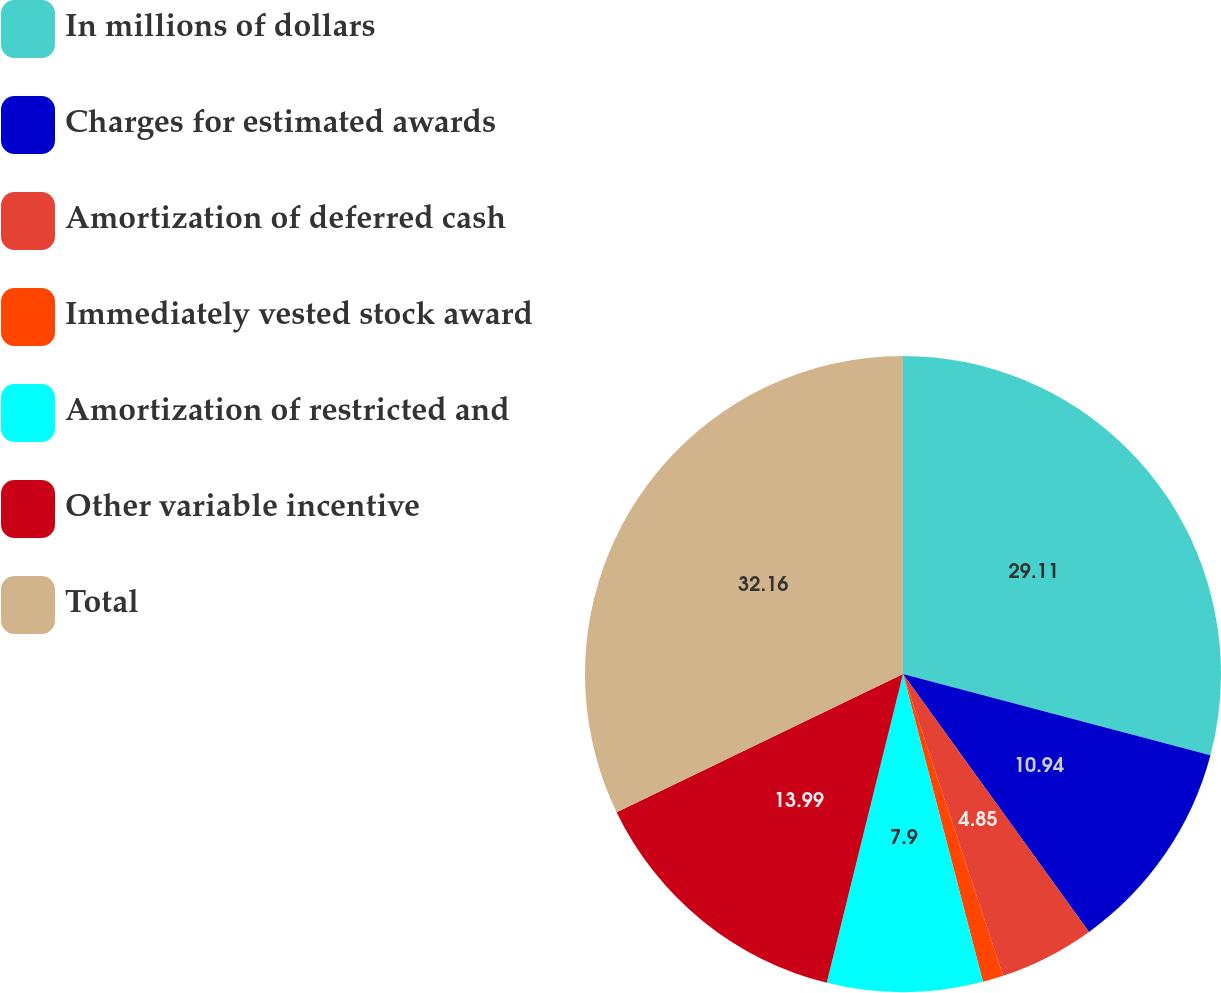Convert chart. <chart><loc_0><loc_0><loc_500><loc_500><pie_chart><fcel>In millions of dollars<fcel>Charges for estimated awards<fcel>Amortization of deferred cash<fcel>Immediately vested stock award<fcel>Amortization of restricted and<fcel>Other variable incentive<fcel>Total<nl><fcel>29.11%<fcel>10.94%<fcel>4.85%<fcel>1.05%<fcel>7.9%<fcel>13.99%<fcel>32.15%<nl></chart> 